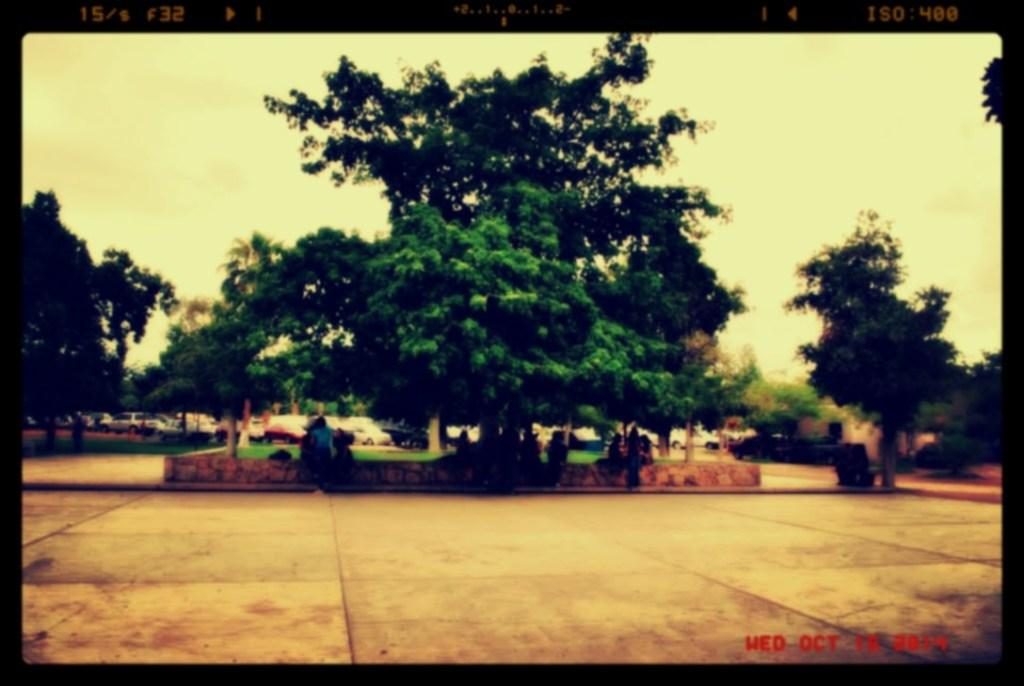What is happening in the center of the image? There are persons sitting in the center of the image. What type of natural elements can be seen in the image? There are trees in the image. What type of vacation is the band taking in the image? There is no band or vacation present in the image; it only features persons sitting and trees. 